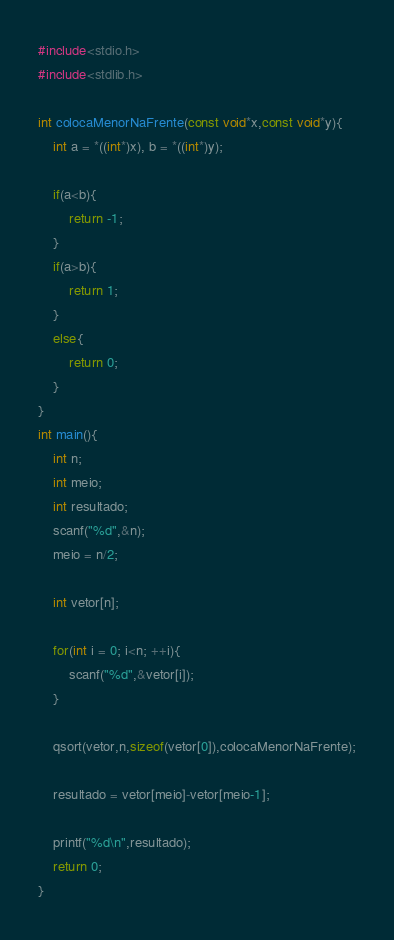Convert code to text. <code><loc_0><loc_0><loc_500><loc_500><_C_>#include<stdio.h>
#include<stdlib.h>

int colocaMenorNaFrente(const void*x,const void*y){
    int a = *((int*)x), b = *((int*)y);

    if(a<b){
        return -1;
    }
    if(a>b){
        return 1;
    }
    else{
        return 0;
    }
}
int main(){
    int n;
    int meio;
    int resultado;
    scanf("%d",&n);
    meio = n/2;

    int vetor[n];

    for(int i = 0; i<n; ++i){
        scanf("%d",&vetor[i]);
    }

    qsort(vetor,n,sizeof(vetor[0]),colocaMenorNaFrente);

    resultado = vetor[meio]-vetor[meio-1];

    printf("%d\n",resultado);
    return 0;
}
</code> 